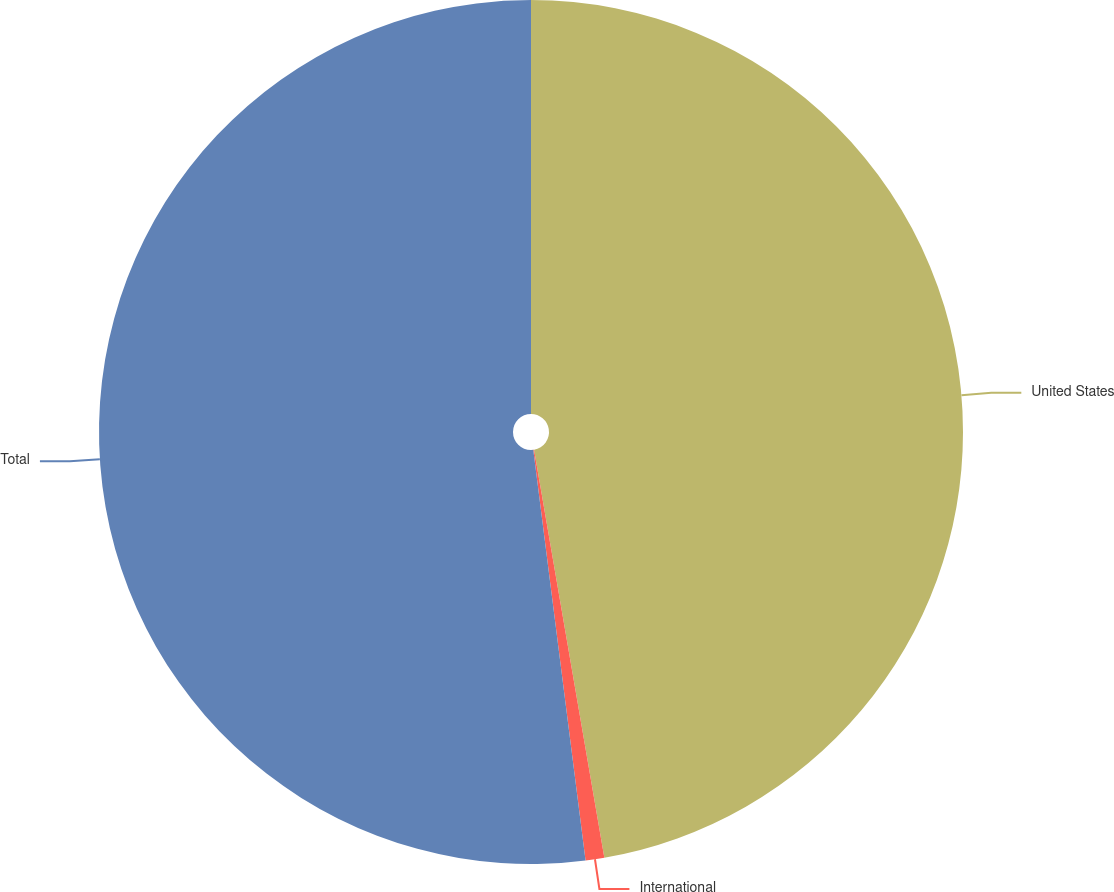Convert chart to OTSL. <chart><loc_0><loc_0><loc_500><loc_500><pie_chart><fcel>United States<fcel>International<fcel>Total<nl><fcel>47.28%<fcel>0.7%<fcel>52.01%<nl></chart> 